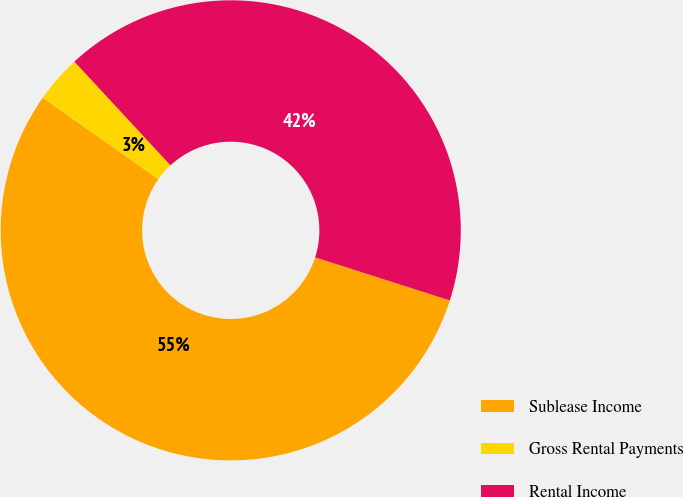Convert chart. <chart><loc_0><loc_0><loc_500><loc_500><pie_chart><fcel>Sublease Income<fcel>Gross Rental Payments<fcel>Rental Income<nl><fcel>54.86%<fcel>3.32%<fcel>41.83%<nl></chart> 